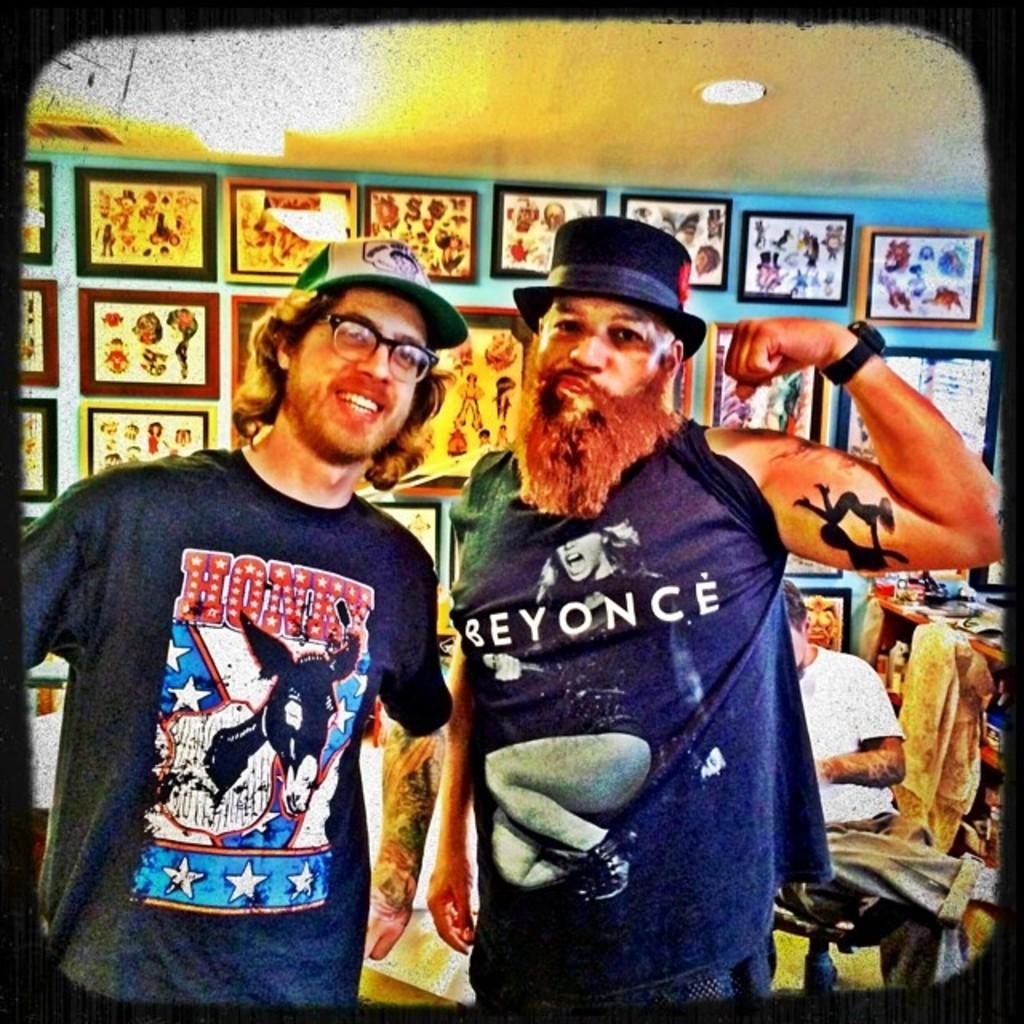Describe this image in one or two sentences. In this picture we can see two men wore caps and standing on the floor and in the background we can see frames on the wall and a person sitting on a chair. 